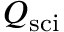<formula> <loc_0><loc_0><loc_500><loc_500>Q _ { s c i }</formula> 